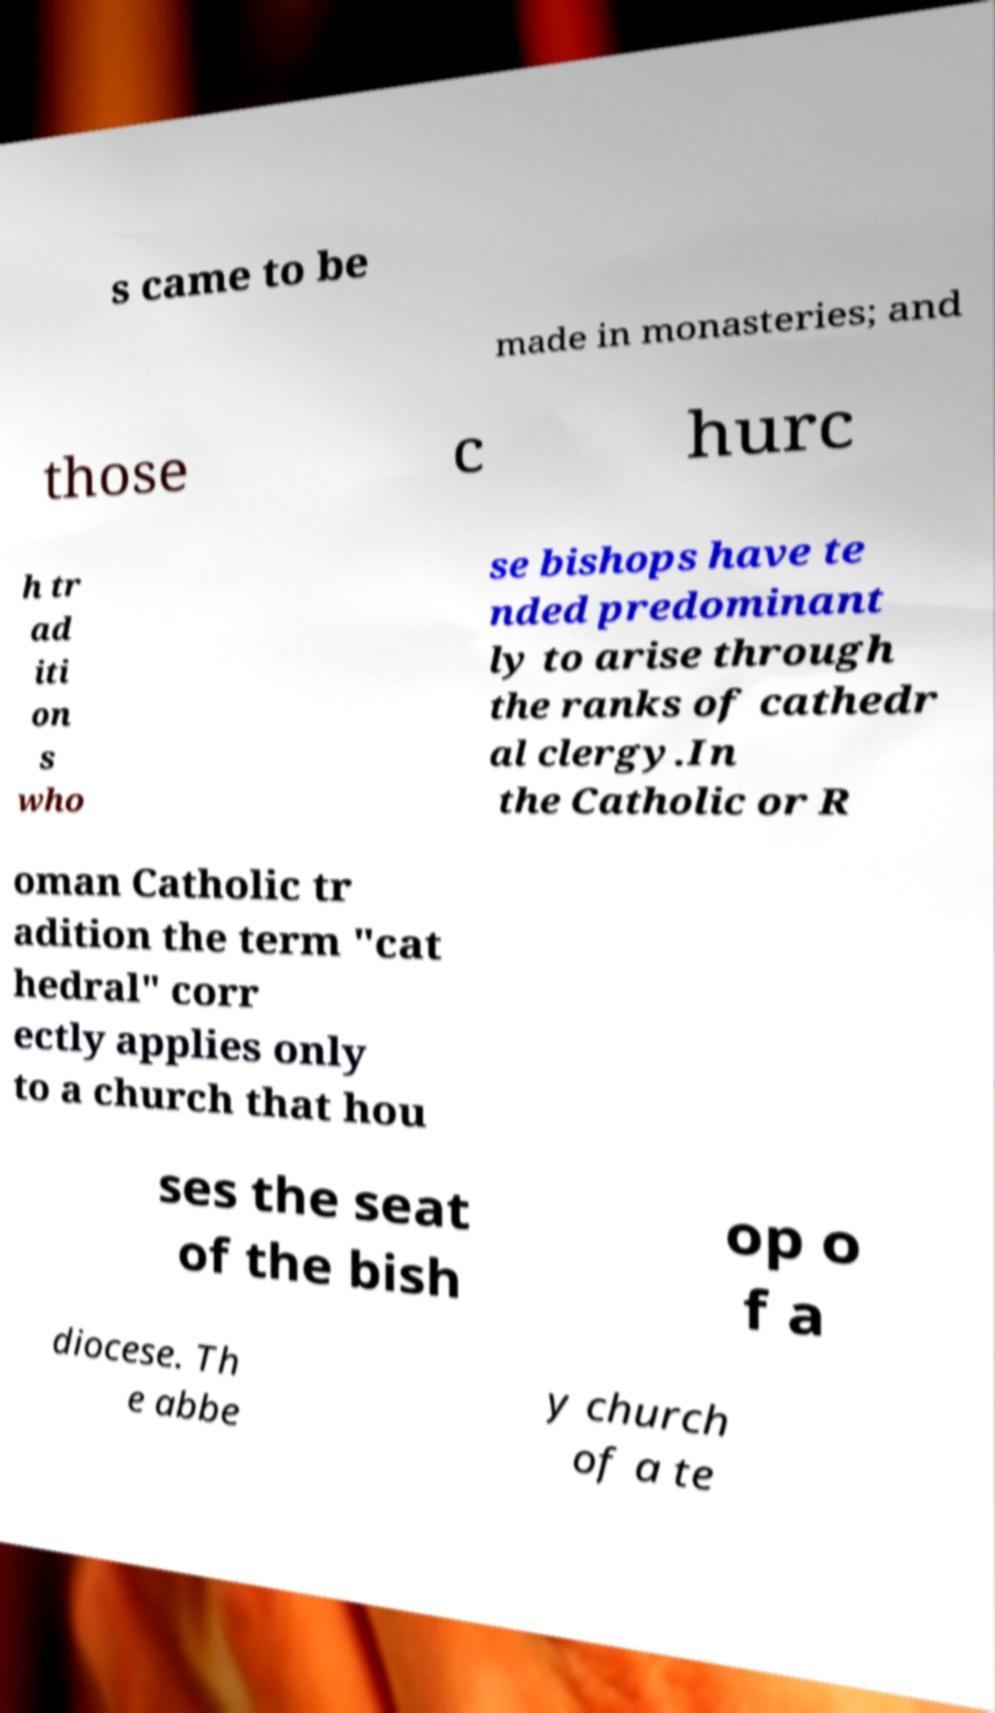Can you read and provide the text displayed in the image?This photo seems to have some interesting text. Can you extract and type it out for me? s came to be made in monasteries; and those c hurc h tr ad iti on s who se bishops have te nded predominant ly to arise through the ranks of cathedr al clergy.In the Catholic or R oman Catholic tr adition the term "cat hedral" corr ectly applies only to a church that hou ses the seat of the bish op o f a diocese. Th e abbe y church of a te 